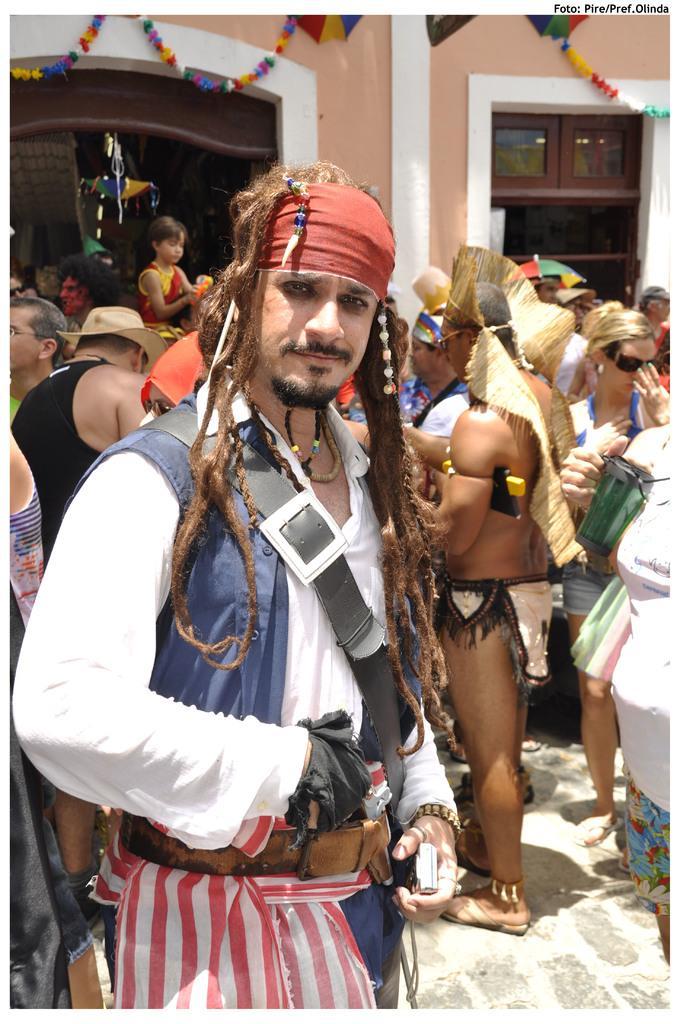Could you give a brief overview of what you see in this image? In this image, we can see a group of people are standing on the platform. Few are wearing hats and goggles. In the middle, a person is smiling and holding some objects. Background we can see wall, door, some objects, glass window, paper crafts. 